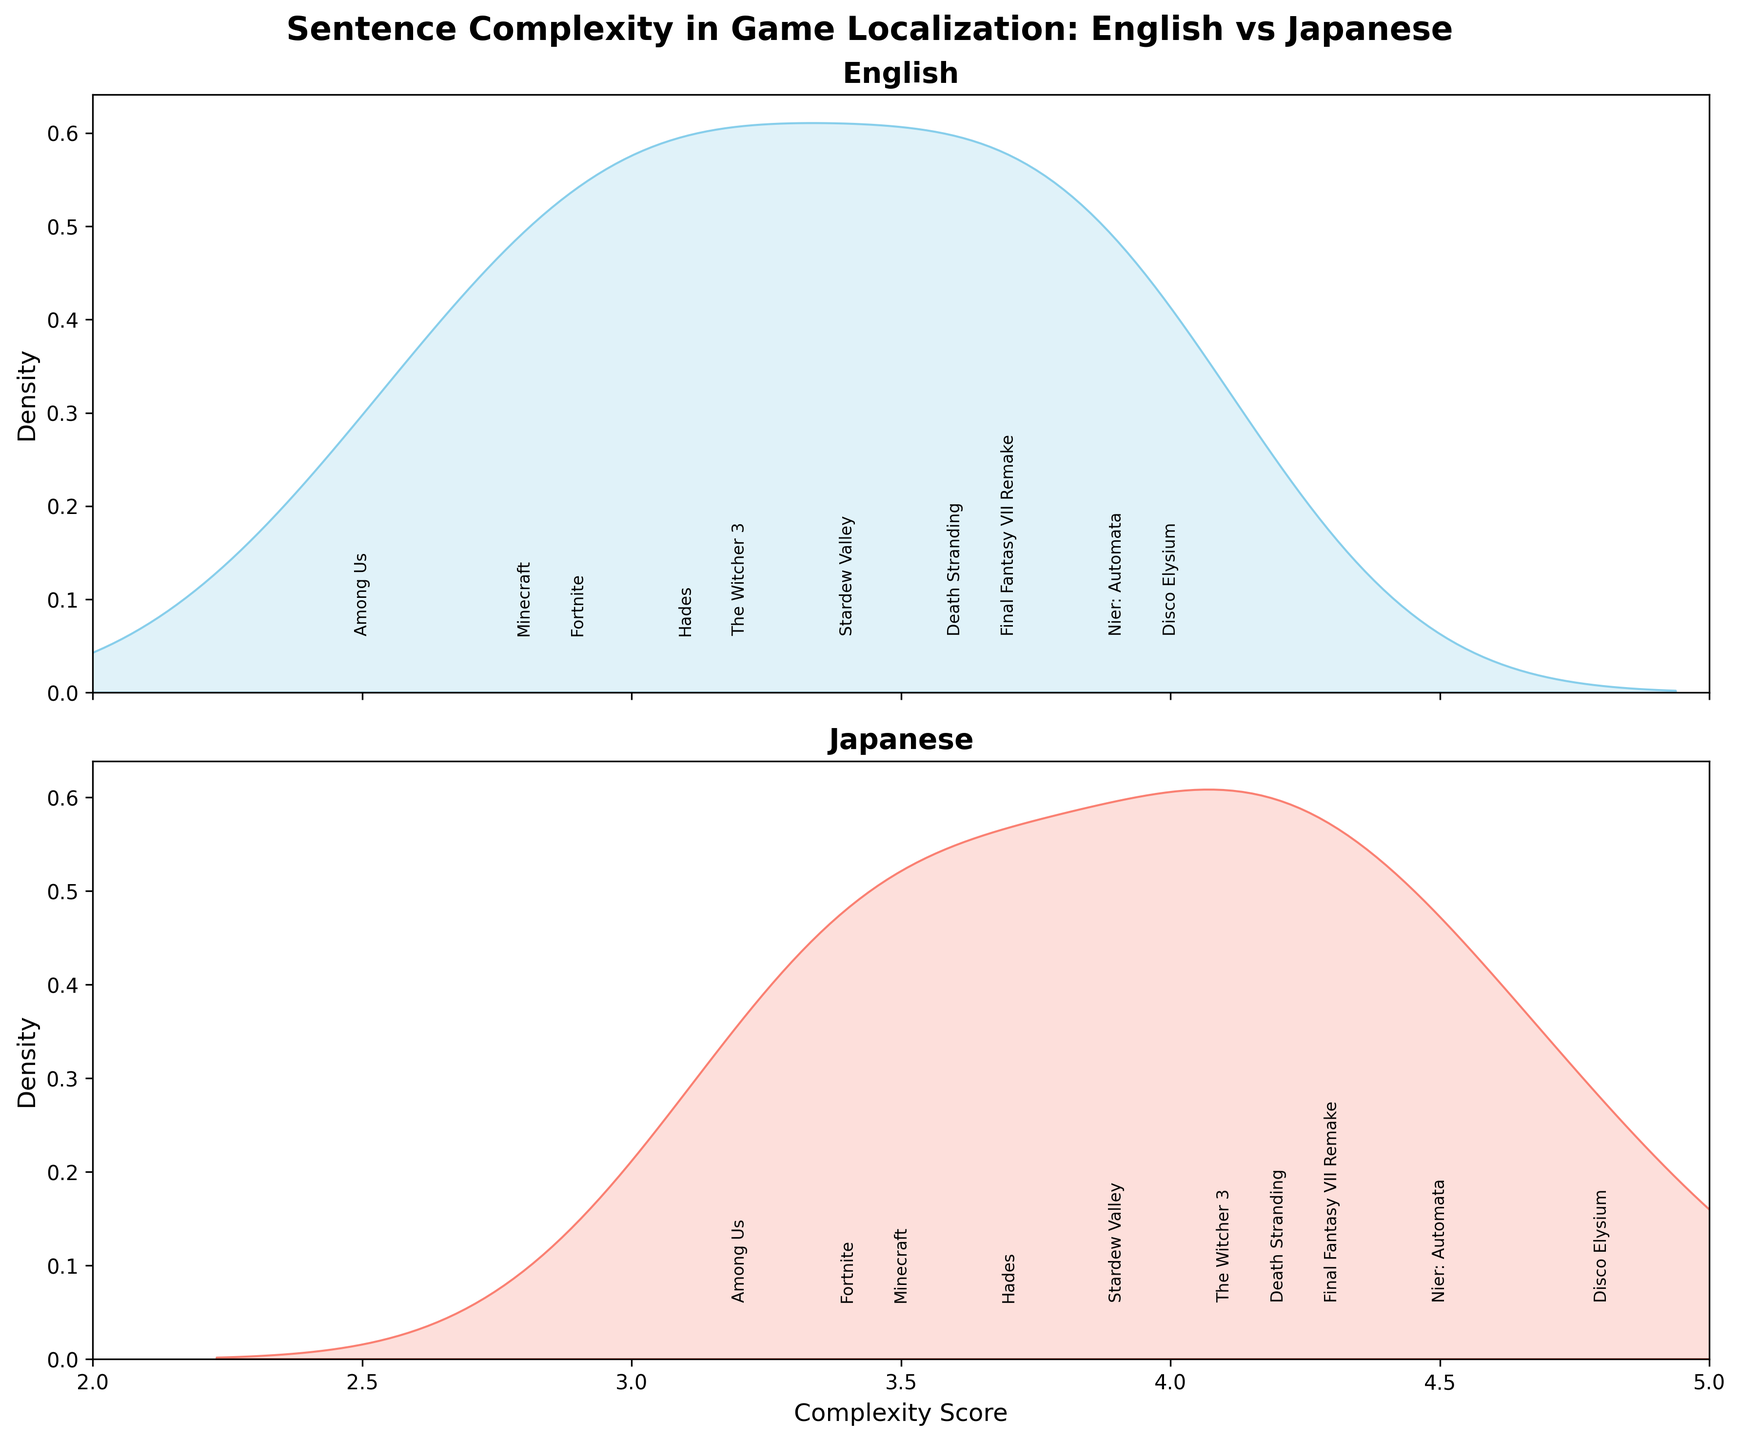What is the title of the figure? The title is shown at the top of the figure. It reads "Sentence Complexity in Game Localization: English vs Japanese".
Answer: Sentence Complexity in Game Localization: English vs Japanese In which language do the sentences have higher complexity, on average? By comparing the peaks of the density plots for English and Japanese, we can observe that the Japanese density plot peaks at a higher complexity score than the English density plot.
Answer: Japanese What is the range of complexity scores shown on the x-axis? The x-axis shows complexity scores ranging from 2 to 5. This can be seen at the bottom of the figure where the axis labels are.
Answer: 2 to 5 Which game has the highest complexity score in Japanese? Looking at the annotations in the Japanese density plot, the highest complexity score is 4.8 for Disco Elysium.
Answer: Disco Elysium Are the density plots shaded? The description and the visual observation of the figure show that both density plots (English and Japanese) are shaded.
Answer: Yes Which game has the lowest complexity score in English? Based on the annotations in the English density plot, the lowest complexity score is 2.5 for Among Us.
Answer: Among Us How does the complexity score for Final Fantasy VII Remake compare between English and Japanese? The English complexity score for Final Fantasy VII Remake is 3.7, and the Japanese complexity score is 4.3. The score is higher in Japanese.
Answer: Higher in Japanese What is the difference in the peak density values between English and Japanese plots? To determine the difference in peak density values, one must compare the highest points of the shaded regions. Upon visual inspection, the Japanese plot has a higher peak density than the English plot.
Answer: Japanese has a higher peak What is the average complexity score of all games in English? The English complexity scores are 3.2, 2.8, 3.7, 2.5, 4.0, 3.4, 3.9, 3.1, 2.9, and 3.6. Summing these values gives a total of 33.1, and the average is 33.1/10 = 3.31.
Answer: 3.31 Based on the density plots, do English complexity scores have a wider range of variability compared to Japanese? The spread of the density plot for English appears wider compared to Japanese, indicating a larger variability in English complexity scores.
Answer: Yes 